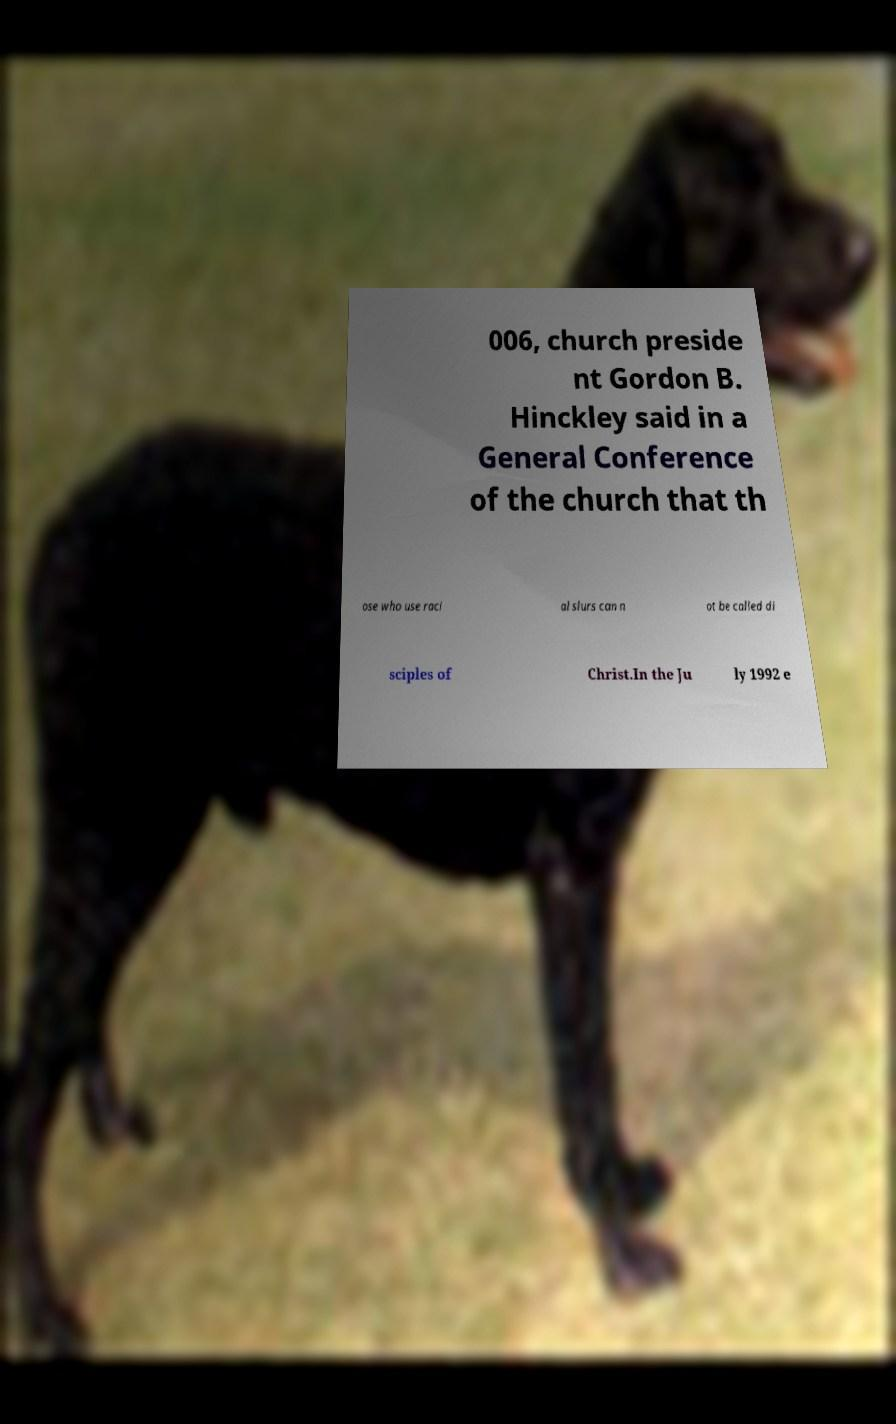Could you extract and type out the text from this image? 006, church preside nt Gordon B. Hinckley said in a General Conference of the church that th ose who use raci al slurs can n ot be called di sciples of Christ.In the Ju ly 1992 e 